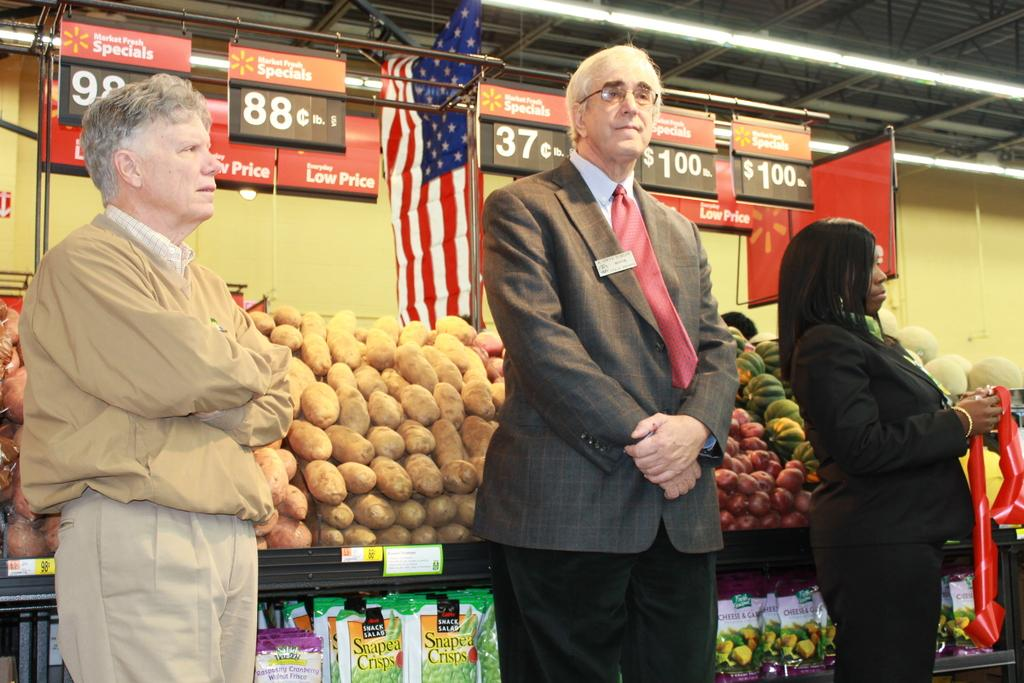<image>
Give a short and clear explanation of the subsequent image. Hanging signs claim low prices while three people stand. 